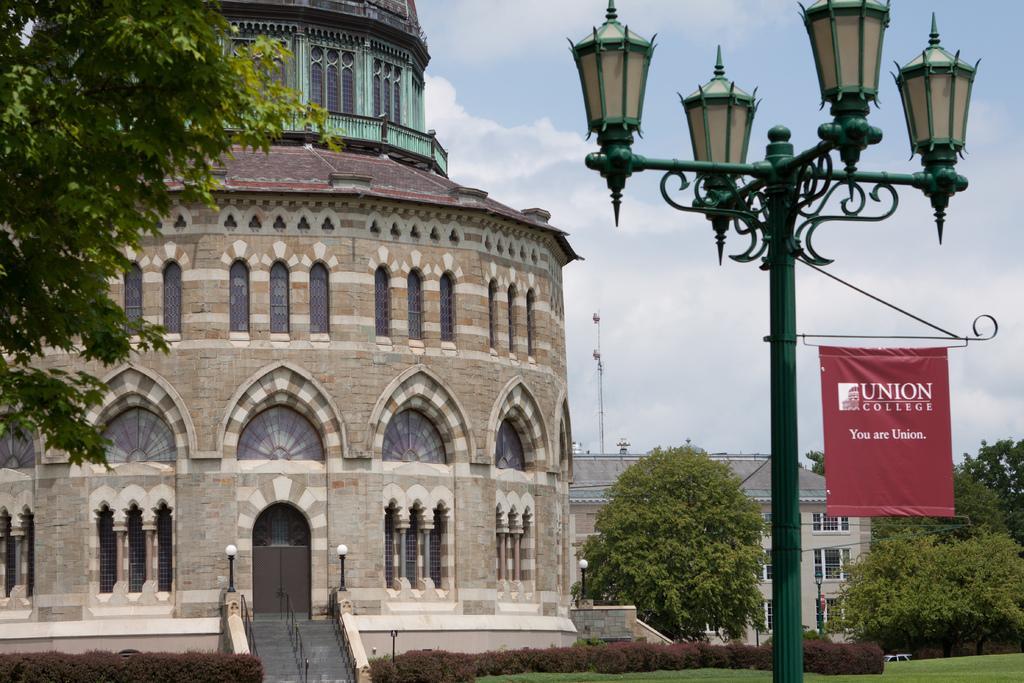Could you give a brief overview of what you see in this image? In this image we can see sky with clouds, street poles, street lights, flag, trees, buildings, staircase, railings, bushes and ground. 